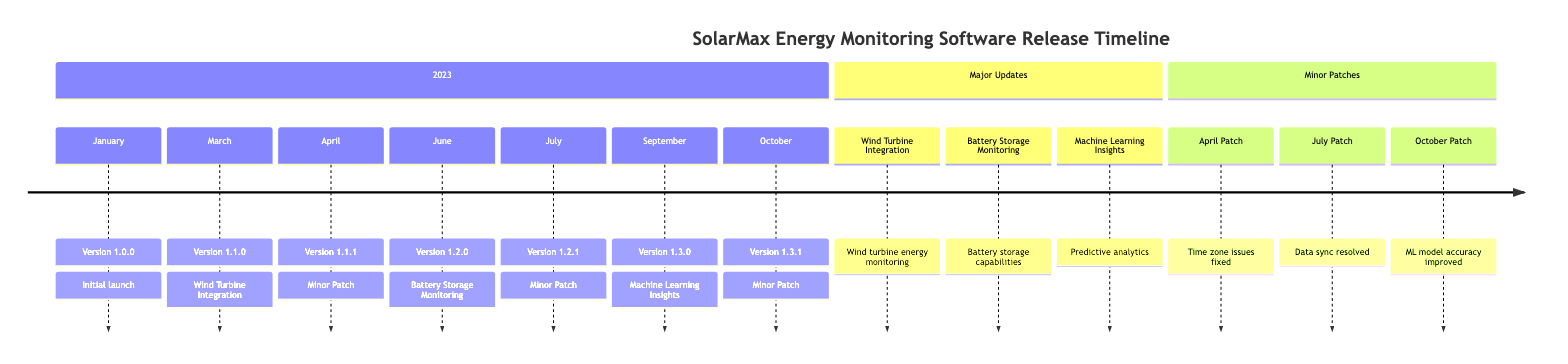What is the date of the initial launch of the software? The diagram indicates that the initial launch of the SolarMax Energy Monitoring Software occurred on January 15, 2023, which is clearly stated next to the release Version 1.0.0.
Answer: January 15, 2023 What features were introduced in Version 1.1.0? To find the features introduced in Version 1.1.0, I look at the section where major updates are noted. It states the features related to wind turbine integration, which include support for wind turbine monitoring and enhanced reporting features.
Answer: Wind turbine energy monitoring, Enhanced reporting features, Improved API How many minor patch updates were released in 2023? By counting the entries labeled as minor patch updates, I see there are three updates: Version 1.1.1, Version 1.2.1, and Version 1.3.1.
Answer: 3 Which version introduced battery storage capabilities? The timeline indicates that Version 1.2.0 introduced battery storage monitoring capabilities, as specified in the major updates section.
Answer: Version 1.2.0 What was the main feature added in the update on September 1, 2023? Looking at the timeline, the update on September 1, 2023, corresponds to Version 1.3.0, which introduced machine learning insights, including predictive analytics for energy usage.
Answer: Predictive analytics for energy usage Which minor patch fixed the issue with machine learning model inaccuracies? By examining the bug fixes in the timeline, I find that the patch released on October 12, 2023, which is Version 1.3.1, fixed the issue with inaccuracies in the machine learning model.
Answer: Version 1.3.1 What is the most recent version released? The latest date in the timeline is October 12, 2023, which corresponds to Version 1.3.1, making it the most recent version released.
Answer: Version 1.3.1 What type of updates are present in the timeline? The timeline categorizes updates into major updates and minor patches, as indicated by specific sections labeled accordingly.
Answer: Major updates and Minor patches What bug was fixed in the April minor patch? Within the entries for the minor patch updates, the April patch (Version 1.1.1) lists several bug fixes, including one for incorrect energy consumption reporting due to time zone issues.
Answer: Incorrect energy consumption reporting due to time zone issues 